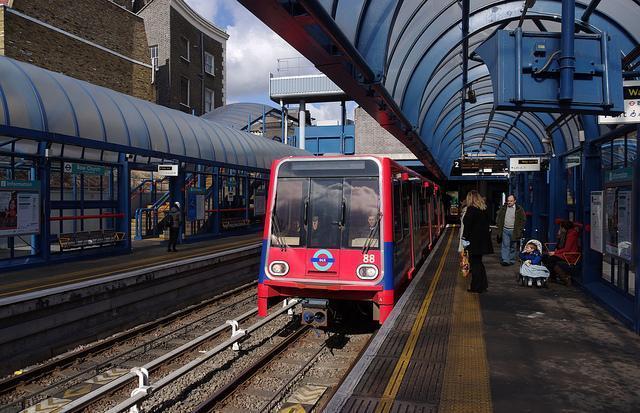How many colors is the train?
Give a very brief answer. 2. How many lights are on the front of the train?
Give a very brief answer. 2. 